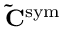<formula> <loc_0><loc_0><loc_500><loc_500>\tilde { C } ^ { s y m }</formula> 